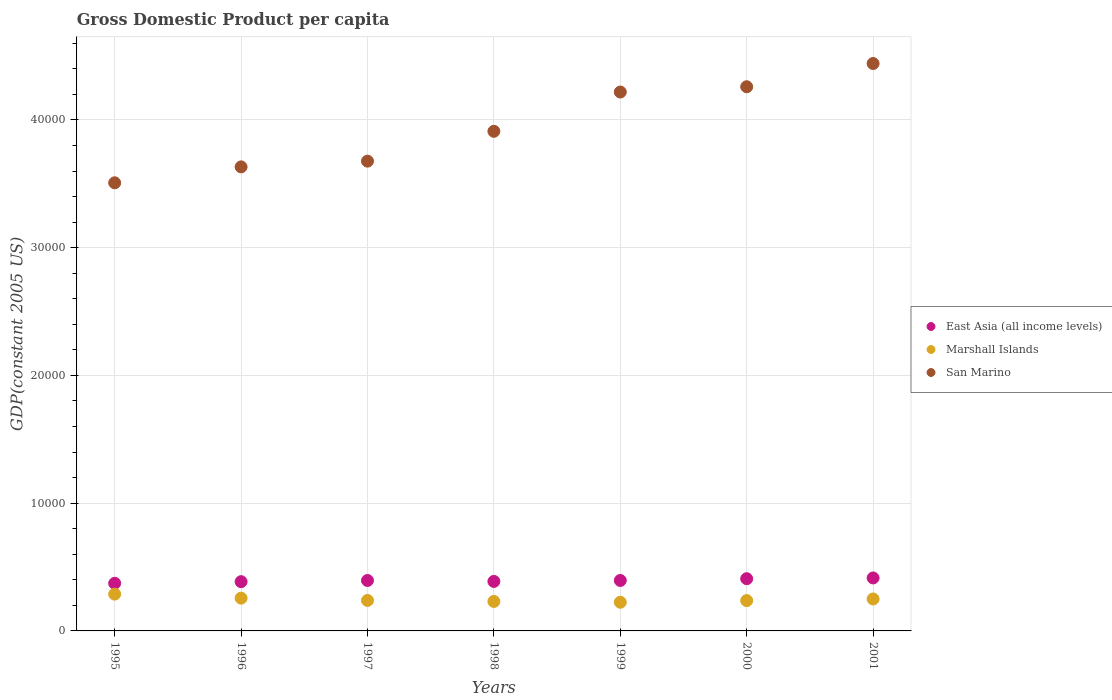What is the GDP per capita in San Marino in 2000?
Provide a short and direct response. 4.26e+04. Across all years, what is the maximum GDP per capita in East Asia (all income levels)?
Provide a succinct answer. 4146.97. Across all years, what is the minimum GDP per capita in East Asia (all income levels)?
Your response must be concise. 3729.46. What is the total GDP per capita in East Asia (all income levels) in the graph?
Your response must be concise. 2.76e+04. What is the difference between the GDP per capita in Marshall Islands in 1996 and that in 1999?
Offer a very short reply. 319.15. What is the difference between the GDP per capita in East Asia (all income levels) in 2000 and the GDP per capita in Marshall Islands in 1996?
Keep it short and to the point. 1523.17. What is the average GDP per capita in East Asia (all income levels) per year?
Ensure brevity in your answer.  3941.84. In the year 1997, what is the difference between the GDP per capita in Marshall Islands and GDP per capita in San Marino?
Provide a succinct answer. -3.44e+04. What is the ratio of the GDP per capita in Marshall Islands in 1995 to that in 1996?
Ensure brevity in your answer.  1.12. Is the GDP per capita in Marshall Islands in 1996 less than that in 2001?
Give a very brief answer. No. What is the difference between the highest and the second highest GDP per capita in Marshall Islands?
Offer a very short reply. 315.76. What is the difference between the highest and the lowest GDP per capita in Marshall Islands?
Keep it short and to the point. 634.91. In how many years, is the GDP per capita in East Asia (all income levels) greater than the average GDP per capita in East Asia (all income levels) taken over all years?
Your answer should be compact. 4. Is it the case that in every year, the sum of the GDP per capita in East Asia (all income levels) and GDP per capita in Marshall Islands  is greater than the GDP per capita in San Marino?
Your answer should be very brief. No. How many years are there in the graph?
Make the answer very short. 7. Does the graph contain any zero values?
Offer a very short reply. No. How are the legend labels stacked?
Provide a succinct answer. Vertical. What is the title of the graph?
Provide a succinct answer. Gross Domestic Product per capita. What is the label or title of the X-axis?
Your answer should be very brief. Years. What is the label or title of the Y-axis?
Offer a terse response. GDP(constant 2005 US). What is the GDP(constant 2005 US) in East Asia (all income levels) in 1995?
Give a very brief answer. 3729.46. What is the GDP(constant 2005 US) in Marshall Islands in 1995?
Provide a short and direct response. 2880.83. What is the GDP(constant 2005 US) in San Marino in 1995?
Ensure brevity in your answer.  3.51e+04. What is the GDP(constant 2005 US) of East Asia (all income levels) in 1996?
Make the answer very short. 3855.23. What is the GDP(constant 2005 US) in Marshall Islands in 1996?
Your answer should be very brief. 2565.07. What is the GDP(constant 2005 US) of San Marino in 1996?
Offer a terse response. 3.63e+04. What is the GDP(constant 2005 US) in East Asia (all income levels) in 1997?
Ensure brevity in your answer.  3947.74. What is the GDP(constant 2005 US) of Marshall Islands in 1997?
Keep it short and to the point. 2385.81. What is the GDP(constant 2005 US) in San Marino in 1997?
Your response must be concise. 3.68e+04. What is the GDP(constant 2005 US) of East Asia (all income levels) in 1998?
Provide a succinct answer. 3875.97. What is the GDP(constant 2005 US) of Marshall Islands in 1998?
Provide a short and direct response. 2307.91. What is the GDP(constant 2005 US) of San Marino in 1998?
Your answer should be compact. 3.91e+04. What is the GDP(constant 2005 US) in East Asia (all income levels) in 1999?
Offer a terse response. 3949.28. What is the GDP(constant 2005 US) in Marshall Islands in 1999?
Your response must be concise. 2245.92. What is the GDP(constant 2005 US) of San Marino in 1999?
Offer a very short reply. 4.22e+04. What is the GDP(constant 2005 US) in East Asia (all income levels) in 2000?
Make the answer very short. 4088.24. What is the GDP(constant 2005 US) of Marshall Islands in 2000?
Provide a short and direct response. 2374.35. What is the GDP(constant 2005 US) in San Marino in 2000?
Your answer should be compact. 4.26e+04. What is the GDP(constant 2005 US) in East Asia (all income levels) in 2001?
Your answer should be very brief. 4146.97. What is the GDP(constant 2005 US) of Marshall Islands in 2001?
Offer a very short reply. 2500.59. What is the GDP(constant 2005 US) of San Marino in 2001?
Your response must be concise. 4.44e+04. Across all years, what is the maximum GDP(constant 2005 US) of East Asia (all income levels)?
Offer a very short reply. 4146.97. Across all years, what is the maximum GDP(constant 2005 US) in Marshall Islands?
Ensure brevity in your answer.  2880.83. Across all years, what is the maximum GDP(constant 2005 US) of San Marino?
Offer a very short reply. 4.44e+04. Across all years, what is the minimum GDP(constant 2005 US) of East Asia (all income levels)?
Give a very brief answer. 3729.46. Across all years, what is the minimum GDP(constant 2005 US) in Marshall Islands?
Give a very brief answer. 2245.92. Across all years, what is the minimum GDP(constant 2005 US) in San Marino?
Give a very brief answer. 3.51e+04. What is the total GDP(constant 2005 US) in East Asia (all income levels) in the graph?
Provide a succinct answer. 2.76e+04. What is the total GDP(constant 2005 US) in Marshall Islands in the graph?
Offer a terse response. 1.73e+04. What is the total GDP(constant 2005 US) of San Marino in the graph?
Ensure brevity in your answer.  2.76e+05. What is the difference between the GDP(constant 2005 US) of East Asia (all income levels) in 1995 and that in 1996?
Make the answer very short. -125.77. What is the difference between the GDP(constant 2005 US) of Marshall Islands in 1995 and that in 1996?
Offer a very short reply. 315.76. What is the difference between the GDP(constant 2005 US) of San Marino in 1995 and that in 1996?
Ensure brevity in your answer.  -1246.56. What is the difference between the GDP(constant 2005 US) of East Asia (all income levels) in 1995 and that in 1997?
Provide a short and direct response. -218.28. What is the difference between the GDP(constant 2005 US) of Marshall Islands in 1995 and that in 1997?
Your answer should be compact. 495.02. What is the difference between the GDP(constant 2005 US) of San Marino in 1995 and that in 1997?
Give a very brief answer. -1696.14. What is the difference between the GDP(constant 2005 US) in East Asia (all income levels) in 1995 and that in 1998?
Make the answer very short. -146.51. What is the difference between the GDP(constant 2005 US) in Marshall Islands in 1995 and that in 1998?
Ensure brevity in your answer.  572.93. What is the difference between the GDP(constant 2005 US) of San Marino in 1995 and that in 1998?
Your answer should be very brief. -4030.72. What is the difference between the GDP(constant 2005 US) in East Asia (all income levels) in 1995 and that in 1999?
Ensure brevity in your answer.  -219.82. What is the difference between the GDP(constant 2005 US) of Marshall Islands in 1995 and that in 1999?
Keep it short and to the point. 634.91. What is the difference between the GDP(constant 2005 US) of San Marino in 1995 and that in 1999?
Keep it short and to the point. -7105.38. What is the difference between the GDP(constant 2005 US) of East Asia (all income levels) in 1995 and that in 2000?
Keep it short and to the point. -358.78. What is the difference between the GDP(constant 2005 US) in Marshall Islands in 1995 and that in 2000?
Provide a succinct answer. 506.49. What is the difference between the GDP(constant 2005 US) of San Marino in 1995 and that in 2000?
Your answer should be very brief. -7518.41. What is the difference between the GDP(constant 2005 US) of East Asia (all income levels) in 1995 and that in 2001?
Your answer should be very brief. -417.51. What is the difference between the GDP(constant 2005 US) in Marshall Islands in 1995 and that in 2001?
Offer a terse response. 380.25. What is the difference between the GDP(constant 2005 US) of San Marino in 1995 and that in 2001?
Offer a terse response. -9338.46. What is the difference between the GDP(constant 2005 US) in East Asia (all income levels) in 1996 and that in 1997?
Make the answer very short. -92.51. What is the difference between the GDP(constant 2005 US) in Marshall Islands in 1996 and that in 1997?
Your answer should be very brief. 179.26. What is the difference between the GDP(constant 2005 US) of San Marino in 1996 and that in 1997?
Offer a terse response. -449.58. What is the difference between the GDP(constant 2005 US) in East Asia (all income levels) in 1996 and that in 1998?
Your answer should be compact. -20.74. What is the difference between the GDP(constant 2005 US) of Marshall Islands in 1996 and that in 1998?
Keep it short and to the point. 257.16. What is the difference between the GDP(constant 2005 US) of San Marino in 1996 and that in 1998?
Provide a short and direct response. -2784.15. What is the difference between the GDP(constant 2005 US) in East Asia (all income levels) in 1996 and that in 1999?
Your response must be concise. -94.05. What is the difference between the GDP(constant 2005 US) of Marshall Islands in 1996 and that in 1999?
Make the answer very short. 319.15. What is the difference between the GDP(constant 2005 US) in San Marino in 1996 and that in 1999?
Give a very brief answer. -5858.82. What is the difference between the GDP(constant 2005 US) of East Asia (all income levels) in 1996 and that in 2000?
Keep it short and to the point. -233.01. What is the difference between the GDP(constant 2005 US) of Marshall Islands in 1996 and that in 2000?
Keep it short and to the point. 190.72. What is the difference between the GDP(constant 2005 US) in San Marino in 1996 and that in 2000?
Ensure brevity in your answer.  -6271.85. What is the difference between the GDP(constant 2005 US) in East Asia (all income levels) in 1996 and that in 2001?
Your answer should be compact. -291.75. What is the difference between the GDP(constant 2005 US) of Marshall Islands in 1996 and that in 2001?
Your answer should be compact. 64.48. What is the difference between the GDP(constant 2005 US) of San Marino in 1996 and that in 2001?
Offer a terse response. -8091.89. What is the difference between the GDP(constant 2005 US) in East Asia (all income levels) in 1997 and that in 1998?
Offer a very short reply. 71.77. What is the difference between the GDP(constant 2005 US) in Marshall Islands in 1997 and that in 1998?
Ensure brevity in your answer.  77.9. What is the difference between the GDP(constant 2005 US) of San Marino in 1997 and that in 1998?
Provide a short and direct response. -2334.57. What is the difference between the GDP(constant 2005 US) in East Asia (all income levels) in 1997 and that in 1999?
Offer a terse response. -1.54. What is the difference between the GDP(constant 2005 US) of Marshall Islands in 1997 and that in 1999?
Provide a short and direct response. 139.89. What is the difference between the GDP(constant 2005 US) of San Marino in 1997 and that in 1999?
Make the answer very short. -5409.24. What is the difference between the GDP(constant 2005 US) in East Asia (all income levels) in 1997 and that in 2000?
Provide a short and direct response. -140.5. What is the difference between the GDP(constant 2005 US) of Marshall Islands in 1997 and that in 2000?
Offer a terse response. 11.46. What is the difference between the GDP(constant 2005 US) of San Marino in 1997 and that in 2000?
Your response must be concise. -5822.27. What is the difference between the GDP(constant 2005 US) of East Asia (all income levels) in 1997 and that in 2001?
Offer a terse response. -199.23. What is the difference between the GDP(constant 2005 US) of Marshall Islands in 1997 and that in 2001?
Your answer should be very brief. -114.78. What is the difference between the GDP(constant 2005 US) in San Marino in 1997 and that in 2001?
Your answer should be very brief. -7642.32. What is the difference between the GDP(constant 2005 US) of East Asia (all income levels) in 1998 and that in 1999?
Give a very brief answer. -73.3. What is the difference between the GDP(constant 2005 US) of Marshall Islands in 1998 and that in 1999?
Offer a very short reply. 61.99. What is the difference between the GDP(constant 2005 US) in San Marino in 1998 and that in 1999?
Make the answer very short. -3074.66. What is the difference between the GDP(constant 2005 US) in East Asia (all income levels) in 1998 and that in 2000?
Make the answer very short. -212.27. What is the difference between the GDP(constant 2005 US) of Marshall Islands in 1998 and that in 2000?
Offer a terse response. -66.44. What is the difference between the GDP(constant 2005 US) in San Marino in 1998 and that in 2000?
Your answer should be compact. -3487.7. What is the difference between the GDP(constant 2005 US) of East Asia (all income levels) in 1998 and that in 2001?
Your answer should be very brief. -271. What is the difference between the GDP(constant 2005 US) in Marshall Islands in 1998 and that in 2001?
Your answer should be compact. -192.68. What is the difference between the GDP(constant 2005 US) of San Marino in 1998 and that in 2001?
Provide a succinct answer. -5307.74. What is the difference between the GDP(constant 2005 US) of East Asia (all income levels) in 1999 and that in 2000?
Make the answer very short. -138.97. What is the difference between the GDP(constant 2005 US) of Marshall Islands in 1999 and that in 2000?
Your response must be concise. -128.42. What is the difference between the GDP(constant 2005 US) in San Marino in 1999 and that in 2000?
Offer a terse response. -413.03. What is the difference between the GDP(constant 2005 US) in East Asia (all income levels) in 1999 and that in 2001?
Keep it short and to the point. -197.7. What is the difference between the GDP(constant 2005 US) of Marshall Islands in 1999 and that in 2001?
Your response must be concise. -254.67. What is the difference between the GDP(constant 2005 US) of San Marino in 1999 and that in 2001?
Ensure brevity in your answer.  -2233.08. What is the difference between the GDP(constant 2005 US) in East Asia (all income levels) in 2000 and that in 2001?
Offer a terse response. -58.73. What is the difference between the GDP(constant 2005 US) of Marshall Islands in 2000 and that in 2001?
Give a very brief answer. -126.24. What is the difference between the GDP(constant 2005 US) of San Marino in 2000 and that in 2001?
Your answer should be compact. -1820.04. What is the difference between the GDP(constant 2005 US) in East Asia (all income levels) in 1995 and the GDP(constant 2005 US) in Marshall Islands in 1996?
Provide a succinct answer. 1164.39. What is the difference between the GDP(constant 2005 US) of East Asia (all income levels) in 1995 and the GDP(constant 2005 US) of San Marino in 1996?
Offer a very short reply. -3.26e+04. What is the difference between the GDP(constant 2005 US) in Marshall Islands in 1995 and the GDP(constant 2005 US) in San Marino in 1996?
Keep it short and to the point. -3.34e+04. What is the difference between the GDP(constant 2005 US) of East Asia (all income levels) in 1995 and the GDP(constant 2005 US) of Marshall Islands in 1997?
Your answer should be very brief. 1343.65. What is the difference between the GDP(constant 2005 US) of East Asia (all income levels) in 1995 and the GDP(constant 2005 US) of San Marino in 1997?
Your answer should be compact. -3.30e+04. What is the difference between the GDP(constant 2005 US) in Marshall Islands in 1995 and the GDP(constant 2005 US) in San Marino in 1997?
Ensure brevity in your answer.  -3.39e+04. What is the difference between the GDP(constant 2005 US) in East Asia (all income levels) in 1995 and the GDP(constant 2005 US) in Marshall Islands in 1998?
Offer a very short reply. 1421.55. What is the difference between the GDP(constant 2005 US) of East Asia (all income levels) in 1995 and the GDP(constant 2005 US) of San Marino in 1998?
Keep it short and to the point. -3.54e+04. What is the difference between the GDP(constant 2005 US) of Marshall Islands in 1995 and the GDP(constant 2005 US) of San Marino in 1998?
Offer a very short reply. -3.62e+04. What is the difference between the GDP(constant 2005 US) of East Asia (all income levels) in 1995 and the GDP(constant 2005 US) of Marshall Islands in 1999?
Give a very brief answer. 1483.54. What is the difference between the GDP(constant 2005 US) in East Asia (all income levels) in 1995 and the GDP(constant 2005 US) in San Marino in 1999?
Your response must be concise. -3.85e+04. What is the difference between the GDP(constant 2005 US) of Marshall Islands in 1995 and the GDP(constant 2005 US) of San Marino in 1999?
Offer a terse response. -3.93e+04. What is the difference between the GDP(constant 2005 US) in East Asia (all income levels) in 1995 and the GDP(constant 2005 US) in Marshall Islands in 2000?
Offer a very short reply. 1355.11. What is the difference between the GDP(constant 2005 US) of East Asia (all income levels) in 1995 and the GDP(constant 2005 US) of San Marino in 2000?
Your response must be concise. -3.89e+04. What is the difference between the GDP(constant 2005 US) of Marshall Islands in 1995 and the GDP(constant 2005 US) of San Marino in 2000?
Give a very brief answer. -3.97e+04. What is the difference between the GDP(constant 2005 US) in East Asia (all income levels) in 1995 and the GDP(constant 2005 US) in Marshall Islands in 2001?
Your response must be concise. 1228.87. What is the difference between the GDP(constant 2005 US) in East Asia (all income levels) in 1995 and the GDP(constant 2005 US) in San Marino in 2001?
Offer a terse response. -4.07e+04. What is the difference between the GDP(constant 2005 US) of Marshall Islands in 1995 and the GDP(constant 2005 US) of San Marino in 2001?
Provide a succinct answer. -4.15e+04. What is the difference between the GDP(constant 2005 US) in East Asia (all income levels) in 1996 and the GDP(constant 2005 US) in Marshall Islands in 1997?
Provide a succinct answer. 1469.42. What is the difference between the GDP(constant 2005 US) of East Asia (all income levels) in 1996 and the GDP(constant 2005 US) of San Marino in 1997?
Keep it short and to the point. -3.29e+04. What is the difference between the GDP(constant 2005 US) of Marshall Islands in 1996 and the GDP(constant 2005 US) of San Marino in 1997?
Give a very brief answer. -3.42e+04. What is the difference between the GDP(constant 2005 US) of East Asia (all income levels) in 1996 and the GDP(constant 2005 US) of Marshall Islands in 1998?
Make the answer very short. 1547.32. What is the difference between the GDP(constant 2005 US) in East Asia (all income levels) in 1996 and the GDP(constant 2005 US) in San Marino in 1998?
Keep it short and to the point. -3.53e+04. What is the difference between the GDP(constant 2005 US) in Marshall Islands in 1996 and the GDP(constant 2005 US) in San Marino in 1998?
Make the answer very short. -3.65e+04. What is the difference between the GDP(constant 2005 US) in East Asia (all income levels) in 1996 and the GDP(constant 2005 US) in Marshall Islands in 1999?
Your response must be concise. 1609.31. What is the difference between the GDP(constant 2005 US) of East Asia (all income levels) in 1996 and the GDP(constant 2005 US) of San Marino in 1999?
Your response must be concise. -3.83e+04. What is the difference between the GDP(constant 2005 US) of Marshall Islands in 1996 and the GDP(constant 2005 US) of San Marino in 1999?
Ensure brevity in your answer.  -3.96e+04. What is the difference between the GDP(constant 2005 US) in East Asia (all income levels) in 1996 and the GDP(constant 2005 US) in Marshall Islands in 2000?
Your response must be concise. 1480.88. What is the difference between the GDP(constant 2005 US) in East Asia (all income levels) in 1996 and the GDP(constant 2005 US) in San Marino in 2000?
Make the answer very short. -3.87e+04. What is the difference between the GDP(constant 2005 US) in Marshall Islands in 1996 and the GDP(constant 2005 US) in San Marino in 2000?
Make the answer very short. -4.00e+04. What is the difference between the GDP(constant 2005 US) of East Asia (all income levels) in 1996 and the GDP(constant 2005 US) of Marshall Islands in 2001?
Give a very brief answer. 1354.64. What is the difference between the GDP(constant 2005 US) of East Asia (all income levels) in 1996 and the GDP(constant 2005 US) of San Marino in 2001?
Keep it short and to the point. -4.06e+04. What is the difference between the GDP(constant 2005 US) of Marshall Islands in 1996 and the GDP(constant 2005 US) of San Marino in 2001?
Your answer should be compact. -4.19e+04. What is the difference between the GDP(constant 2005 US) in East Asia (all income levels) in 1997 and the GDP(constant 2005 US) in Marshall Islands in 1998?
Provide a succinct answer. 1639.83. What is the difference between the GDP(constant 2005 US) in East Asia (all income levels) in 1997 and the GDP(constant 2005 US) in San Marino in 1998?
Offer a very short reply. -3.52e+04. What is the difference between the GDP(constant 2005 US) in Marshall Islands in 1997 and the GDP(constant 2005 US) in San Marino in 1998?
Ensure brevity in your answer.  -3.67e+04. What is the difference between the GDP(constant 2005 US) of East Asia (all income levels) in 1997 and the GDP(constant 2005 US) of Marshall Islands in 1999?
Keep it short and to the point. 1701.82. What is the difference between the GDP(constant 2005 US) of East Asia (all income levels) in 1997 and the GDP(constant 2005 US) of San Marino in 1999?
Keep it short and to the point. -3.82e+04. What is the difference between the GDP(constant 2005 US) of Marshall Islands in 1997 and the GDP(constant 2005 US) of San Marino in 1999?
Make the answer very short. -3.98e+04. What is the difference between the GDP(constant 2005 US) of East Asia (all income levels) in 1997 and the GDP(constant 2005 US) of Marshall Islands in 2000?
Your answer should be very brief. 1573.39. What is the difference between the GDP(constant 2005 US) of East Asia (all income levels) in 1997 and the GDP(constant 2005 US) of San Marino in 2000?
Offer a very short reply. -3.86e+04. What is the difference between the GDP(constant 2005 US) in Marshall Islands in 1997 and the GDP(constant 2005 US) in San Marino in 2000?
Provide a short and direct response. -4.02e+04. What is the difference between the GDP(constant 2005 US) in East Asia (all income levels) in 1997 and the GDP(constant 2005 US) in Marshall Islands in 2001?
Provide a succinct answer. 1447.15. What is the difference between the GDP(constant 2005 US) of East Asia (all income levels) in 1997 and the GDP(constant 2005 US) of San Marino in 2001?
Your answer should be compact. -4.05e+04. What is the difference between the GDP(constant 2005 US) in Marshall Islands in 1997 and the GDP(constant 2005 US) in San Marino in 2001?
Provide a short and direct response. -4.20e+04. What is the difference between the GDP(constant 2005 US) in East Asia (all income levels) in 1998 and the GDP(constant 2005 US) in Marshall Islands in 1999?
Your response must be concise. 1630.05. What is the difference between the GDP(constant 2005 US) in East Asia (all income levels) in 1998 and the GDP(constant 2005 US) in San Marino in 1999?
Provide a succinct answer. -3.83e+04. What is the difference between the GDP(constant 2005 US) in Marshall Islands in 1998 and the GDP(constant 2005 US) in San Marino in 1999?
Provide a succinct answer. -3.99e+04. What is the difference between the GDP(constant 2005 US) in East Asia (all income levels) in 1998 and the GDP(constant 2005 US) in Marshall Islands in 2000?
Your answer should be compact. 1501.63. What is the difference between the GDP(constant 2005 US) of East Asia (all income levels) in 1998 and the GDP(constant 2005 US) of San Marino in 2000?
Offer a terse response. -3.87e+04. What is the difference between the GDP(constant 2005 US) of Marshall Islands in 1998 and the GDP(constant 2005 US) of San Marino in 2000?
Ensure brevity in your answer.  -4.03e+04. What is the difference between the GDP(constant 2005 US) in East Asia (all income levels) in 1998 and the GDP(constant 2005 US) in Marshall Islands in 2001?
Provide a succinct answer. 1375.38. What is the difference between the GDP(constant 2005 US) in East Asia (all income levels) in 1998 and the GDP(constant 2005 US) in San Marino in 2001?
Your response must be concise. -4.05e+04. What is the difference between the GDP(constant 2005 US) of Marshall Islands in 1998 and the GDP(constant 2005 US) of San Marino in 2001?
Your answer should be very brief. -4.21e+04. What is the difference between the GDP(constant 2005 US) in East Asia (all income levels) in 1999 and the GDP(constant 2005 US) in Marshall Islands in 2000?
Your answer should be compact. 1574.93. What is the difference between the GDP(constant 2005 US) in East Asia (all income levels) in 1999 and the GDP(constant 2005 US) in San Marino in 2000?
Provide a succinct answer. -3.86e+04. What is the difference between the GDP(constant 2005 US) in Marshall Islands in 1999 and the GDP(constant 2005 US) in San Marino in 2000?
Provide a short and direct response. -4.04e+04. What is the difference between the GDP(constant 2005 US) in East Asia (all income levels) in 1999 and the GDP(constant 2005 US) in Marshall Islands in 2001?
Keep it short and to the point. 1448.69. What is the difference between the GDP(constant 2005 US) in East Asia (all income levels) in 1999 and the GDP(constant 2005 US) in San Marino in 2001?
Offer a very short reply. -4.05e+04. What is the difference between the GDP(constant 2005 US) of Marshall Islands in 1999 and the GDP(constant 2005 US) of San Marino in 2001?
Provide a succinct answer. -4.22e+04. What is the difference between the GDP(constant 2005 US) in East Asia (all income levels) in 2000 and the GDP(constant 2005 US) in Marshall Islands in 2001?
Offer a terse response. 1587.65. What is the difference between the GDP(constant 2005 US) in East Asia (all income levels) in 2000 and the GDP(constant 2005 US) in San Marino in 2001?
Ensure brevity in your answer.  -4.03e+04. What is the difference between the GDP(constant 2005 US) of Marshall Islands in 2000 and the GDP(constant 2005 US) of San Marino in 2001?
Your response must be concise. -4.20e+04. What is the average GDP(constant 2005 US) in East Asia (all income levels) per year?
Give a very brief answer. 3941.84. What is the average GDP(constant 2005 US) of Marshall Islands per year?
Your answer should be very brief. 2465.78. What is the average GDP(constant 2005 US) of San Marino per year?
Your answer should be compact. 3.95e+04. In the year 1995, what is the difference between the GDP(constant 2005 US) in East Asia (all income levels) and GDP(constant 2005 US) in Marshall Islands?
Offer a terse response. 848.63. In the year 1995, what is the difference between the GDP(constant 2005 US) in East Asia (all income levels) and GDP(constant 2005 US) in San Marino?
Offer a very short reply. -3.13e+04. In the year 1995, what is the difference between the GDP(constant 2005 US) of Marshall Islands and GDP(constant 2005 US) of San Marino?
Your answer should be compact. -3.22e+04. In the year 1996, what is the difference between the GDP(constant 2005 US) of East Asia (all income levels) and GDP(constant 2005 US) of Marshall Islands?
Offer a very short reply. 1290.16. In the year 1996, what is the difference between the GDP(constant 2005 US) of East Asia (all income levels) and GDP(constant 2005 US) of San Marino?
Your answer should be compact. -3.25e+04. In the year 1996, what is the difference between the GDP(constant 2005 US) in Marshall Islands and GDP(constant 2005 US) in San Marino?
Your response must be concise. -3.38e+04. In the year 1997, what is the difference between the GDP(constant 2005 US) in East Asia (all income levels) and GDP(constant 2005 US) in Marshall Islands?
Make the answer very short. 1561.93. In the year 1997, what is the difference between the GDP(constant 2005 US) in East Asia (all income levels) and GDP(constant 2005 US) in San Marino?
Keep it short and to the point. -3.28e+04. In the year 1997, what is the difference between the GDP(constant 2005 US) of Marshall Islands and GDP(constant 2005 US) of San Marino?
Provide a short and direct response. -3.44e+04. In the year 1998, what is the difference between the GDP(constant 2005 US) in East Asia (all income levels) and GDP(constant 2005 US) in Marshall Islands?
Your answer should be compact. 1568.06. In the year 1998, what is the difference between the GDP(constant 2005 US) of East Asia (all income levels) and GDP(constant 2005 US) of San Marino?
Provide a succinct answer. -3.52e+04. In the year 1998, what is the difference between the GDP(constant 2005 US) in Marshall Islands and GDP(constant 2005 US) in San Marino?
Ensure brevity in your answer.  -3.68e+04. In the year 1999, what is the difference between the GDP(constant 2005 US) in East Asia (all income levels) and GDP(constant 2005 US) in Marshall Islands?
Your answer should be very brief. 1703.35. In the year 1999, what is the difference between the GDP(constant 2005 US) of East Asia (all income levels) and GDP(constant 2005 US) of San Marino?
Ensure brevity in your answer.  -3.82e+04. In the year 1999, what is the difference between the GDP(constant 2005 US) in Marshall Islands and GDP(constant 2005 US) in San Marino?
Your answer should be compact. -3.99e+04. In the year 2000, what is the difference between the GDP(constant 2005 US) in East Asia (all income levels) and GDP(constant 2005 US) in Marshall Islands?
Provide a short and direct response. 1713.9. In the year 2000, what is the difference between the GDP(constant 2005 US) of East Asia (all income levels) and GDP(constant 2005 US) of San Marino?
Offer a terse response. -3.85e+04. In the year 2000, what is the difference between the GDP(constant 2005 US) in Marshall Islands and GDP(constant 2005 US) in San Marino?
Your answer should be compact. -4.02e+04. In the year 2001, what is the difference between the GDP(constant 2005 US) of East Asia (all income levels) and GDP(constant 2005 US) of Marshall Islands?
Your answer should be very brief. 1646.39. In the year 2001, what is the difference between the GDP(constant 2005 US) in East Asia (all income levels) and GDP(constant 2005 US) in San Marino?
Your response must be concise. -4.03e+04. In the year 2001, what is the difference between the GDP(constant 2005 US) of Marshall Islands and GDP(constant 2005 US) of San Marino?
Ensure brevity in your answer.  -4.19e+04. What is the ratio of the GDP(constant 2005 US) in East Asia (all income levels) in 1995 to that in 1996?
Offer a very short reply. 0.97. What is the ratio of the GDP(constant 2005 US) in Marshall Islands in 1995 to that in 1996?
Ensure brevity in your answer.  1.12. What is the ratio of the GDP(constant 2005 US) in San Marino in 1995 to that in 1996?
Keep it short and to the point. 0.97. What is the ratio of the GDP(constant 2005 US) of East Asia (all income levels) in 1995 to that in 1997?
Your answer should be very brief. 0.94. What is the ratio of the GDP(constant 2005 US) in Marshall Islands in 1995 to that in 1997?
Make the answer very short. 1.21. What is the ratio of the GDP(constant 2005 US) of San Marino in 1995 to that in 1997?
Keep it short and to the point. 0.95. What is the ratio of the GDP(constant 2005 US) in East Asia (all income levels) in 1995 to that in 1998?
Provide a succinct answer. 0.96. What is the ratio of the GDP(constant 2005 US) of Marshall Islands in 1995 to that in 1998?
Your answer should be very brief. 1.25. What is the ratio of the GDP(constant 2005 US) of San Marino in 1995 to that in 1998?
Make the answer very short. 0.9. What is the ratio of the GDP(constant 2005 US) in East Asia (all income levels) in 1995 to that in 1999?
Offer a very short reply. 0.94. What is the ratio of the GDP(constant 2005 US) in Marshall Islands in 1995 to that in 1999?
Ensure brevity in your answer.  1.28. What is the ratio of the GDP(constant 2005 US) of San Marino in 1995 to that in 1999?
Offer a very short reply. 0.83. What is the ratio of the GDP(constant 2005 US) in East Asia (all income levels) in 1995 to that in 2000?
Your answer should be very brief. 0.91. What is the ratio of the GDP(constant 2005 US) of Marshall Islands in 1995 to that in 2000?
Offer a terse response. 1.21. What is the ratio of the GDP(constant 2005 US) of San Marino in 1995 to that in 2000?
Your answer should be compact. 0.82. What is the ratio of the GDP(constant 2005 US) in East Asia (all income levels) in 1995 to that in 2001?
Keep it short and to the point. 0.9. What is the ratio of the GDP(constant 2005 US) in Marshall Islands in 1995 to that in 2001?
Your answer should be compact. 1.15. What is the ratio of the GDP(constant 2005 US) of San Marino in 1995 to that in 2001?
Ensure brevity in your answer.  0.79. What is the ratio of the GDP(constant 2005 US) of East Asia (all income levels) in 1996 to that in 1997?
Your response must be concise. 0.98. What is the ratio of the GDP(constant 2005 US) in Marshall Islands in 1996 to that in 1997?
Provide a short and direct response. 1.08. What is the ratio of the GDP(constant 2005 US) of San Marino in 1996 to that in 1997?
Provide a succinct answer. 0.99. What is the ratio of the GDP(constant 2005 US) in Marshall Islands in 1996 to that in 1998?
Keep it short and to the point. 1.11. What is the ratio of the GDP(constant 2005 US) of San Marino in 1996 to that in 1998?
Make the answer very short. 0.93. What is the ratio of the GDP(constant 2005 US) in East Asia (all income levels) in 1996 to that in 1999?
Your answer should be compact. 0.98. What is the ratio of the GDP(constant 2005 US) of Marshall Islands in 1996 to that in 1999?
Keep it short and to the point. 1.14. What is the ratio of the GDP(constant 2005 US) in San Marino in 1996 to that in 1999?
Your response must be concise. 0.86. What is the ratio of the GDP(constant 2005 US) of East Asia (all income levels) in 1996 to that in 2000?
Give a very brief answer. 0.94. What is the ratio of the GDP(constant 2005 US) in Marshall Islands in 1996 to that in 2000?
Give a very brief answer. 1.08. What is the ratio of the GDP(constant 2005 US) in San Marino in 1996 to that in 2000?
Your answer should be very brief. 0.85. What is the ratio of the GDP(constant 2005 US) in East Asia (all income levels) in 1996 to that in 2001?
Your answer should be compact. 0.93. What is the ratio of the GDP(constant 2005 US) in Marshall Islands in 1996 to that in 2001?
Keep it short and to the point. 1.03. What is the ratio of the GDP(constant 2005 US) of San Marino in 1996 to that in 2001?
Offer a terse response. 0.82. What is the ratio of the GDP(constant 2005 US) of East Asia (all income levels) in 1997 to that in 1998?
Offer a very short reply. 1.02. What is the ratio of the GDP(constant 2005 US) of Marshall Islands in 1997 to that in 1998?
Provide a succinct answer. 1.03. What is the ratio of the GDP(constant 2005 US) in San Marino in 1997 to that in 1998?
Provide a succinct answer. 0.94. What is the ratio of the GDP(constant 2005 US) of East Asia (all income levels) in 1997 to that in 1999?
Ensure brevity in your answer.  1. What is the ratio of the GDP(constant 2005 US) of Marshall Islands in 1997 to that in 1999?
Provide a succinct answer. 1.06. What is the ratio of the GDP(constant 2005 US) in San Marino in 1997 to that in 1999?
Your response must be concise. 0.87. What is the ratio of the GDP(constant 2005 US) in East Asia (all income levels) in 1997 to that in 2000?
Ensure brevity in your answer.  0.97. What is the ratio of the GDP(constant 2005 US) in Marshall Islands in 1997 to that in 2000?
Offer a terse response. 1. What is the ratio of the GDP(constant 2005 US) in San Marino in 1997 to that in 2000?
Offer a very short reply. 0.86. What is the ratio of the GDP(constant 2005 US) of Marshall Islands in 1997 to that in 2001?
Provide a short and direct response. 0.95. What is the ratio of the GDP(constant 2005 US) in San Marino in 1997 to that in 2001?
Ensure brevity in your answer.  0.83. What is the ratio of the GDP(constant 2005 US) of East Asia (all income levels) in 1998 to that in 1999?
Make the answer very short. 0.98. What is the ratio of the GDP(constant 2005 US) of Marshall Islands in 1998 to that in 1999?
Keep it short and to the point. 1.03. What is the ratio of the GDP(constant 2005 US) in San Marino in 1998 to that in 1999?
Offer a terse response. 0.93. What is the ratio of the GDP(constant 2005 US) in East Asia (all income levels) in 1998 to that in 2000?
Keep it short and to the point. 0.95. What is the ratio of the GDP(constant 2005 US) of Marshall Islands in 1998 to that in 2000?
Your answer should be compact. 0.97. What is the ratio of the GDP(constant 2005 US) of San Marino in 1998 to that in 2000?
Make the answer very short. 0.92. What is the ratio of the GDP(constant 2005 US) in East Asia (all income levels) in 1998 to that in 2001?
Give a very brief answer. 0.93. What is the ratio of the GDP(constant 2005 US) in Marshall Islands in 1998 to that in 2001?
Offer a very short reply. 0.92. What is the ratio of the GDP(constant 2005 US) in San Marino in 1998 to that in 2001?
Keep it short and to the point. 0.88. What is the ratio of the GDP(constant 2005 US) of East Asia (all income levels) in 1999 to that in 2000?
Your response must be concise. 0.97. What is the ratio of the GDP(constant 2005 US) in Marshall Islands in 1999 to that in 2000?
Provide a succinct answer. 0.95. What is the ratio of the GDP(constant 2005 US) in San Marino in 1999 to that in 2000?
Ensure brevity in your answer.  0.99. What is the ratio of the GDP(constant 2005 US) in East Asia (all income levels) in 1999 to that in 2001?
Make the answer very short. 0.95. What is the ratio of the GDP(constant 2005 US) in Marshall Islands in 1999 to that in 2001?
Keep it short and to the point. 0.9. What is the ratio of the GDP(constant 2005 US) of San Marino in 1999 to that in 2001?
Your response must be concise. 0.95. What is the ratio of the GDP(constant 2005 US) of East Asia (all income levels) in 2000 to that in 2001?
Your response must be concise. 0.99. What is the ratio of the GDP(constant 2005 US) of Marshall Islands in 2000 to that in 2001?
Offer a very short reply. 0.95. What is the ratio of the GDP(constant 2005 US) in San Marino in 2000 to that in 2001?
Ensure brevity in your answer.  0.96. What is the difference between the highest and the second highest GDP(constant 2005 US) of East Asia (all income levels)?
Offer a very short reply. 58.73. What is the difference between the highest and the second highest GDP(constant 2005 US) in Marshall Islands?
Offer a terse response. 315.76. What is the difference between the highest and the second highest GDP(constant 2005 US) of San Marino?
Make the answer very short. 1820.04. What is the difference between the highest and the lowest GDP(constant 2005 US) in East Asia (all income levels)?
Provide a succinct answer. 417.51. What is the difference between the highest and the lowest GDP(constant 2005 US) in Marshall Islands?
Offer a terse response. 634.91. What is the difference between the highest and the lowest GDP(constant 2005 US) in San Marino?
Offer a very short reply. 9338.46. 